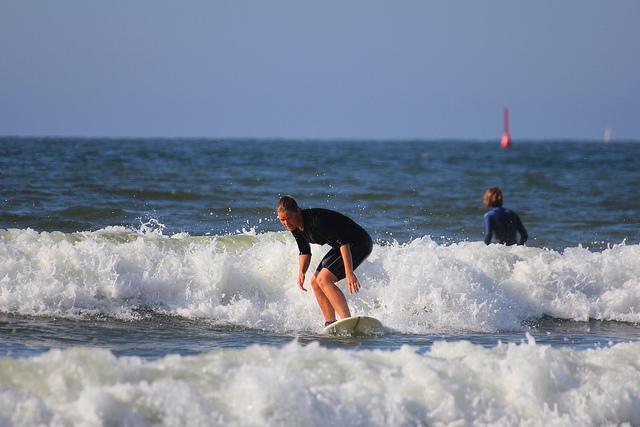How many People are there?
Give a very brief answer. 2. 